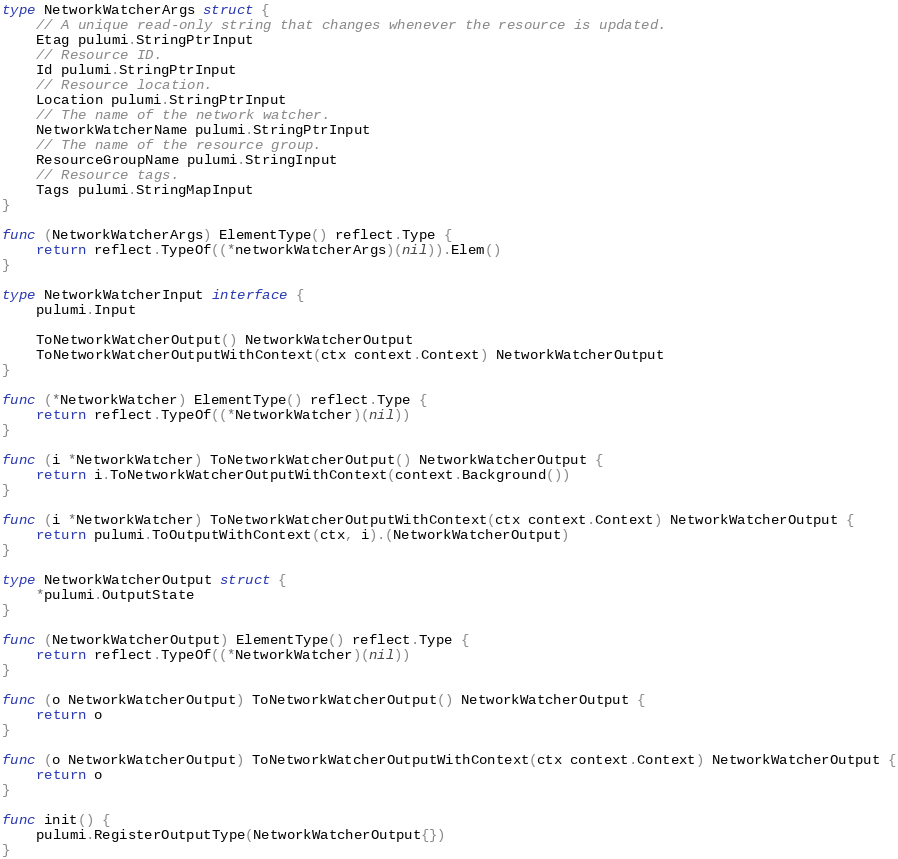<code> <loc_0><loc_0><loc_500><loc_500><_Go_>type NetworkWatcherArgs struct {
	// A unique read-only string that changes whenever the resource is updated.
	Etag pulumi.StringPtrInput
	// Resource ID.
	Id pulumi.StringPtrInput
	// Resource location.
	Location pulumi.StringPtrInput
	// The name of the network watcher.
	NetworkWatcherName pulumi.StringPtrInput
	// The name of the resource group.
	ResourceGroupName pulumi.StringInput
	// Resource tags.
	Tags pulumi.StringMapInput
}

func (NetworkWatcherArgs) ElementType() reflect.Type {
	return reflect.TypeOf((*networkWatcherArgs)(nil)).Elem()
}

type NetworkWatcherInput interface {
	pulumi.Input

	ToNetworkWatcherOutput() NetworkWatcherOutput
	ToNetworkWatcherOutputWithContext(ctx context.Context) NetworkWatcherOutput
}

func (*NetworkWatcher) ElementType() reflect.Type {
	return reflect.TypeOf((*NetworkWatcher)(nil))
}

func (i *NetworkWatcher) ToNetworkWatcherOutput() NetworkWatcherOutput {
	return i.ToNetworkWatcherOutputWithContext(context.Background())
}

func (i *NetworkWatcher) ToNetworkWatcherOutputWithContext(ctx context.Context) NetworkWatcherOutput {
	return pulumi.ToOutputWithContext(ctx, i).(NetworkWatcherOutput)
}

type NetworkWatcherOutput struct {
	*pulumi.OutputState
}

func (NetworkWatcherOutput) ElementType() reflect.Type {
	return reflect.TypeOf((*NetworkWatcher)(nil))
}

func (o NetworkWatcherOutput) ToNetworkWatcherOutput() NetworkWatcherOutput {
	return o
}

func (o NetworkWatcherOutput) ToNetworkWatcherOutputWithContext(ctx context.Context) NetworkWatcherOutput {
	return o
}

func init() {
	pulumi.RegisterOutputType(NetworkWatcherOutput{})
}
</code> 